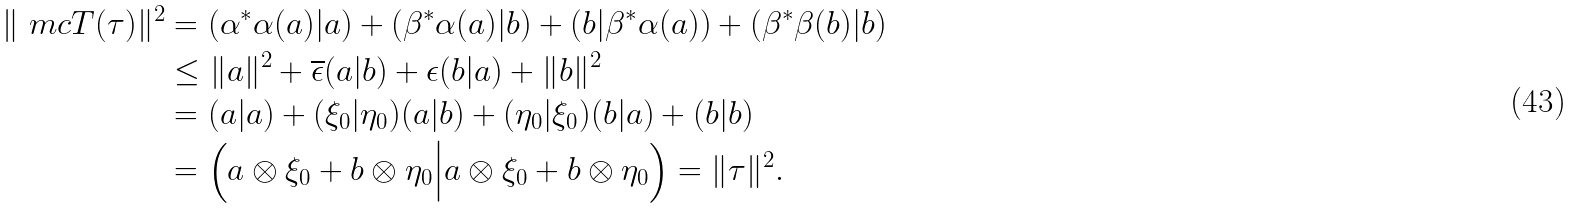Convert formula to latex. <formula><loc_0><loc_0><loc_500><loc_500>\| \ m c T ( \tau ) \| ^ { 2 } & = ( \alpha ^ { * } \alpha ( a ) | a ) + ( \beta ^ { * } \alpha ( a ) | b ) + ( b | \beta ^ { * } \alpha ( a ) ) + ( \beta ^ { * } \beta ( b ) | b ) \\ & \leq \| a \| ^ { 2 } + \overline { \epsilon } ( a | b ) + \epsilon ( b | a ) + \| b \| ^ { 2 } \\ & = ( a | a ) + ( \xi _ { 0 } | \eta _ { 0 } ) ( a | b ) + ( \eta _ { 0 } | \xi _ { 0 } ) ( b | a ) + ( b | b ) \\ & = \Big ( a \otimes \xi _ { 0 } + b \otimes \eta _ { 0 } \Big | a \otimes \xi _ { 0 } + b \otimes \eta _ { 0 } \Big ) = \| \tau \| ^ { 2 } .</formula> 